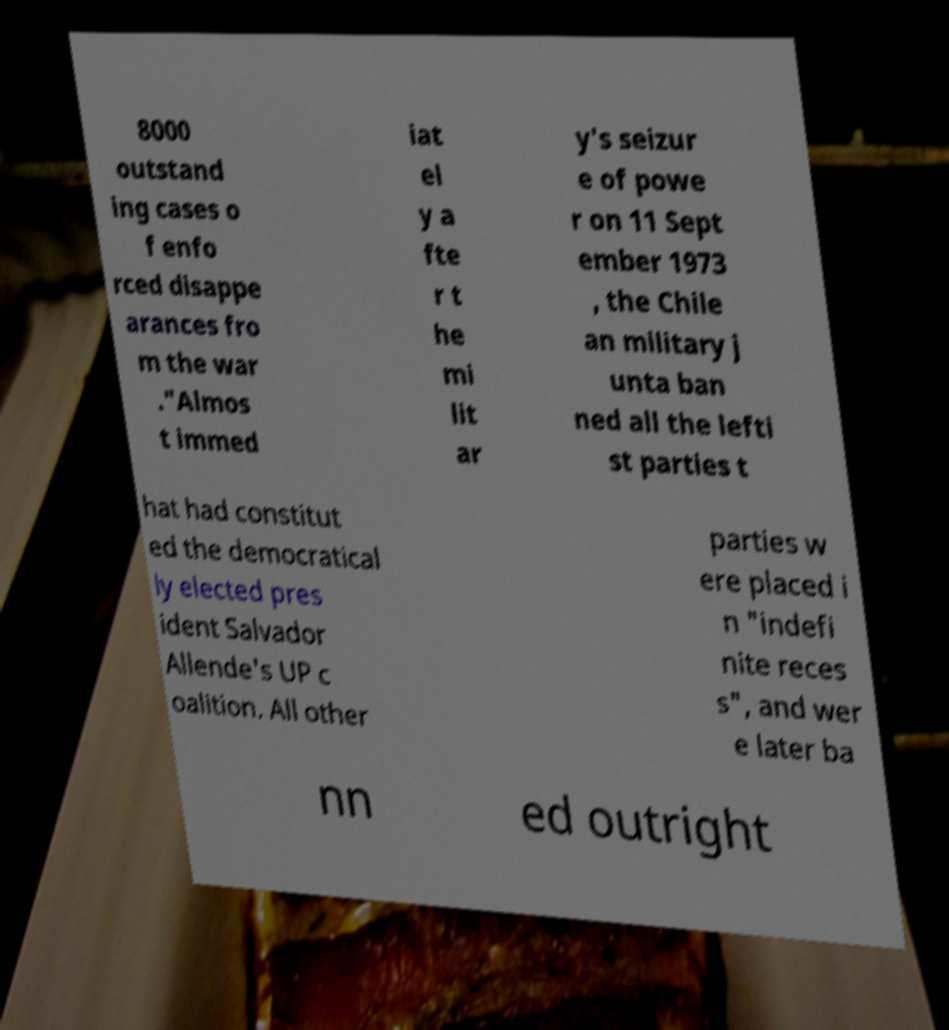Please identify and transcribe the text found in this image. 8000 outstand ing cases o f enfo rced disappe arances fro m the war ."Almos t immed iat el y a fte r t he mi lit ar y's seizur e of powe r on 11 Sept ember 1973 , the Chile an military j unta ban ned all the lefti st parties t hat had constitut ed the democratical ly elected pres ident Salvador Allende's UP c oalition. All other parties w ere placed i n "indefi nite reces s", and wer e later ba nn ed outright 